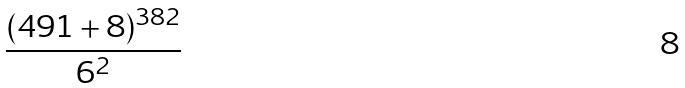Convert formula to latex. <formula><loc_0><loc_0><loc_500><loc_500>\frac { ( 4 9 1 + 8 ) ^ { 3 8 2 } } { 6 ^ { 2 } }</formula> 